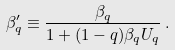<formula> <loc_0><loc_0><loc_500><loc_500>\beta _ { q } ^ { \prime } \equiv \frac { \beta _ { q } } { 1 + ( 1 - q ) \beta _ { q } U _ { q } } \, .</formula> 